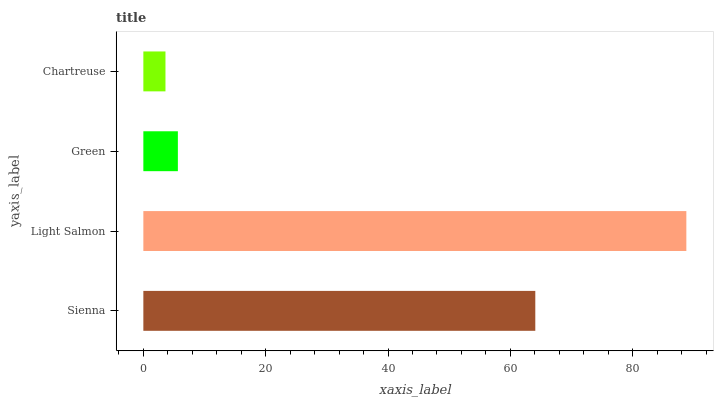Is Chartreuse the minimum?
Answer yes or no. Yes. Is Light Salmon the maximum?
Answer yes or no. Yes. Is Green the minimum?
Answer yes or no. No. Is Green the maximum?
Answer yes or no. No. Is Light Salmon greater than Green?
Answer yes or no. Yes. Is Green less than Light Salmon?
Answer yes or no. Yes. Is Green greater than Light Salmon?
Answer yes or no. No. Is Light Salmon less than Green?
Answer yes or no. No. Is Sienna the high median?
Answer yes or no. Yes. Is Green the low median?
Answer yes or no. Yes. Is Green the high median?
Answer yes or no. No. Is Light Salmon the low median?
Answer yes or no. No. 